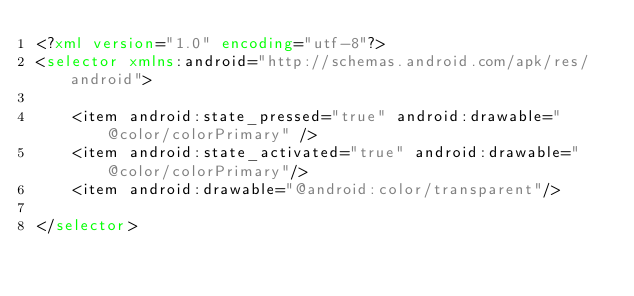Convert code to text. <code><loc_0><loc_0><loc_500><loc_500><_XML_><?xml version="1.0" encoding="utf-8"?>
<selector xmlns:android="http://schemas.android.com/apk/res/android">

    <item android:state_pressed="true" android:drawable="@color/colorPrimary" />
    <item android:state_activated="true" android:drawable="@color/colorPrimary"/>
    <item android:drawable="@android:color/transparent"/>

</selector></code> 